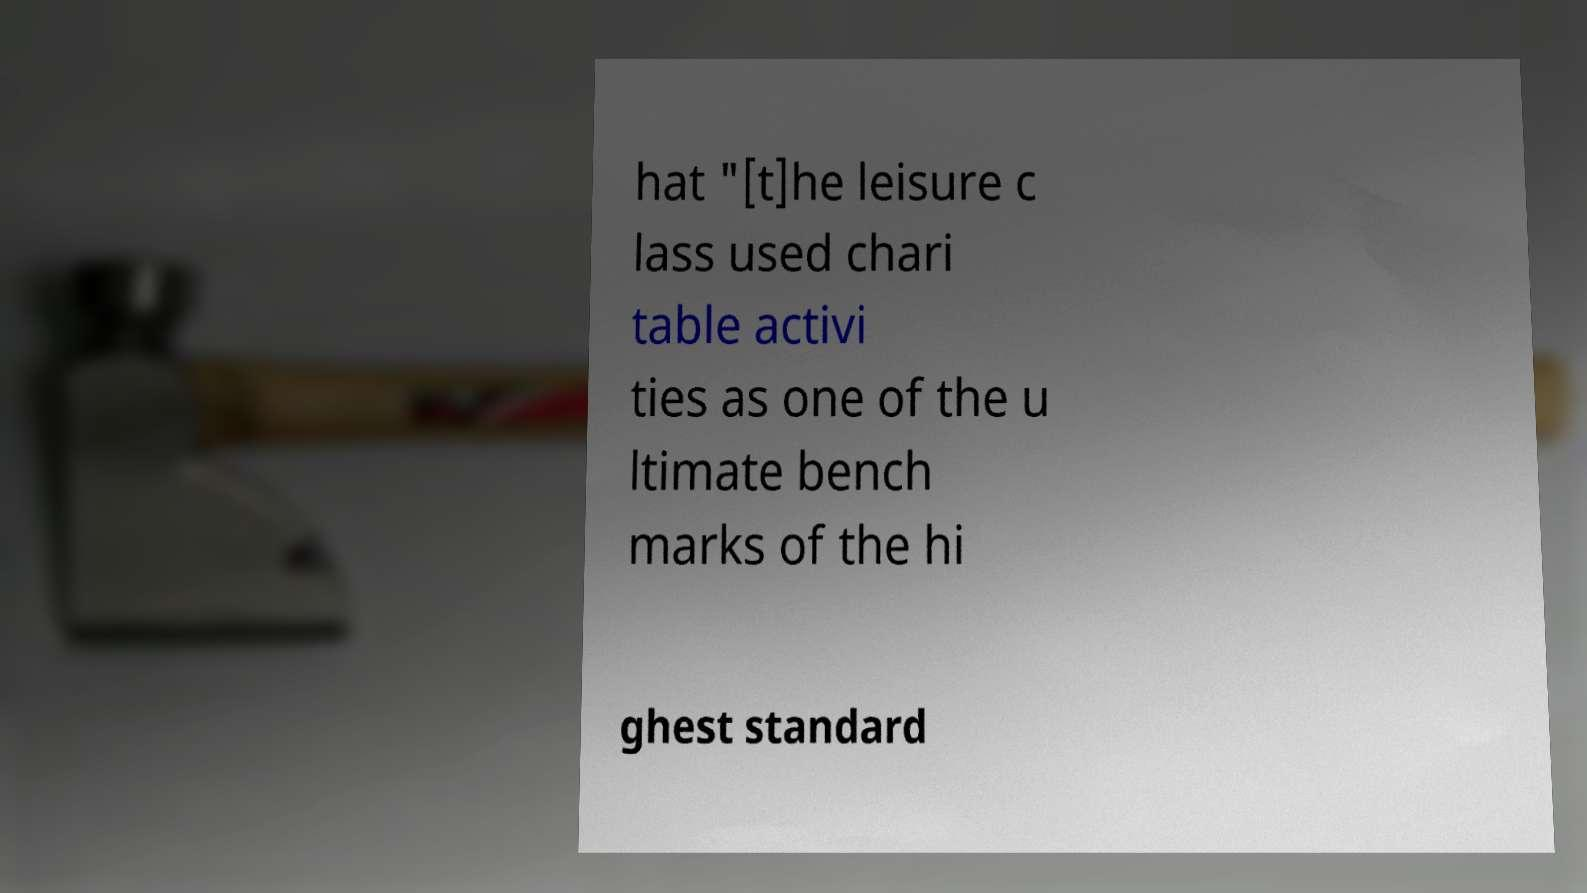What messages or text are displayed in this image? I need them in a readable, typed format. hat "[t]he leisure c lass used chari table activi ties as one of the u ltimate bench marks of the hi ghest standard 